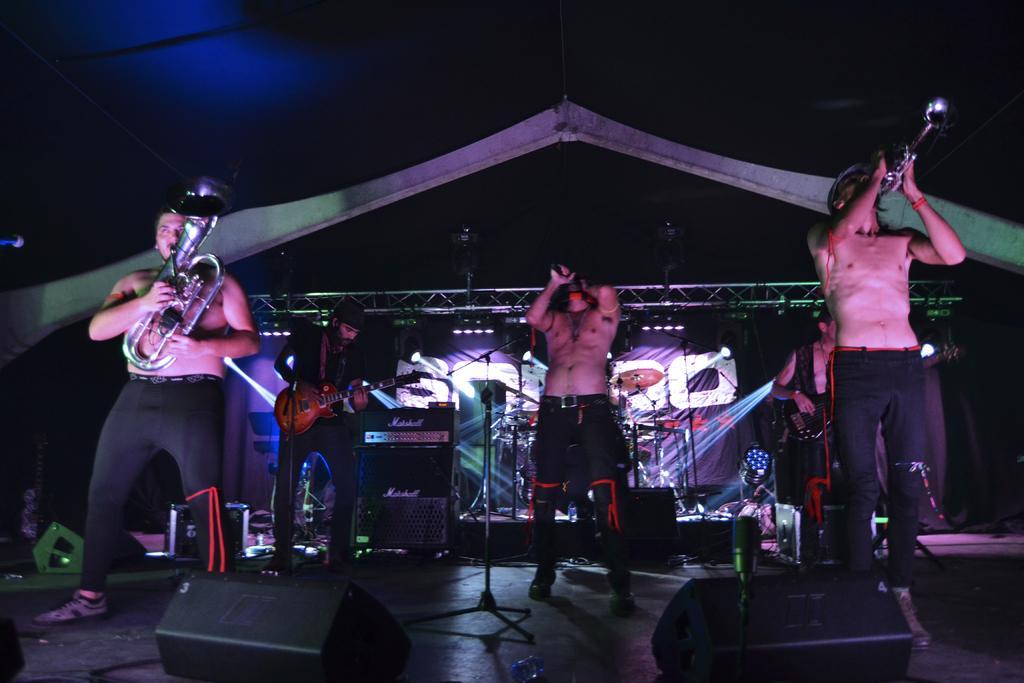Describe this image in one or two sentences. In the middle of the image a man is holding microphone. Bottom Right side of the image few people are playing some musical instruments. Bottom left side of the image few people are playing some musical instruments. At the top of the image there is a roof. 